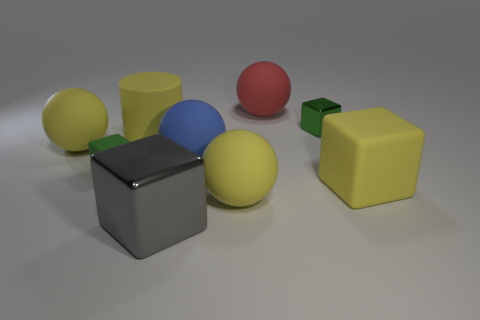There is another yellow thing that is the same shape as the tiny shiny thing; what size is it?
Provide a succinct answer. Large. Are there any blue balls on the right side of the red rubber ball?
Give a very brief answer. No. What is the large yellow cylinder made of?
Make the answer very short. Rubber. There is a small thing on the left side of the big gray object; what shape is it?
Offer a very short reply. Cube. What size is the block that is the same color as the cylinder?
Offer a terse response. Large. Is there a yellow rubber cylinder that has the same size as the gray metallic object?
Your response must be concise. Yes. Is the material of the green block that is left of the big gray metal cube the same as the red object?
Your answer should be compact. Yes. Are there an equal number of large cylinders to the right of the big yellow matte cylinder and red things that are in front of the large metallic block?
Make the answer very short. Yes. There is a thing that is right of the large red thing and behind the green matte block; what shape is it?
Your answer should be compact. Cube. There is a gray cube; how many green matte things are on the right side of it?
Keep it short and to the point. 0. 